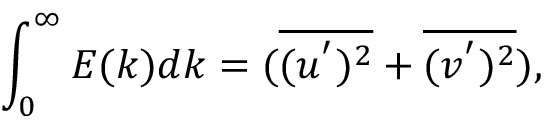Convert formula to latex. <formula><loc_0><loc_0><loc_500><loc_500>\int _ { 0 } ^ { \infty } E ( k ) d k = ( \overline { { ( u ^ { ^ { \prime } } ) ^ { 2 } } } + \overline { { ( v ^ { ^ { \prime } } ) ^ { 2 } } } ) ,</formula> 